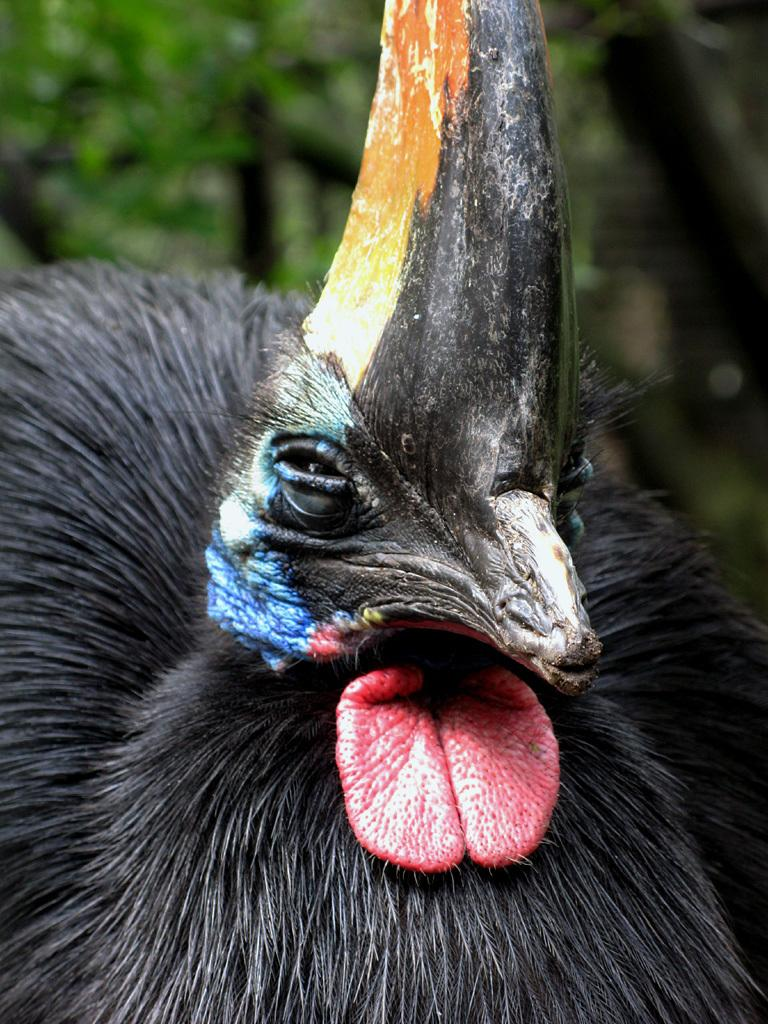What type of animal can be seen in the image? There is a bird in the image. What can be seen in the background of the image? There are trees in the background of the image. What type of horn is the bird using to communicate in the image? There is no horn present in the image, and birds do not use horns to communicate. 